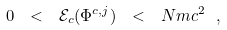<formula> <loc_0><loc_0><loc_500><loc_500>0 \ < \ { \mathcal { E } _ { c } } ( \Phi ^ { c , j } ) \ < \ N m c ^ { 2 } \ ,</formula> 